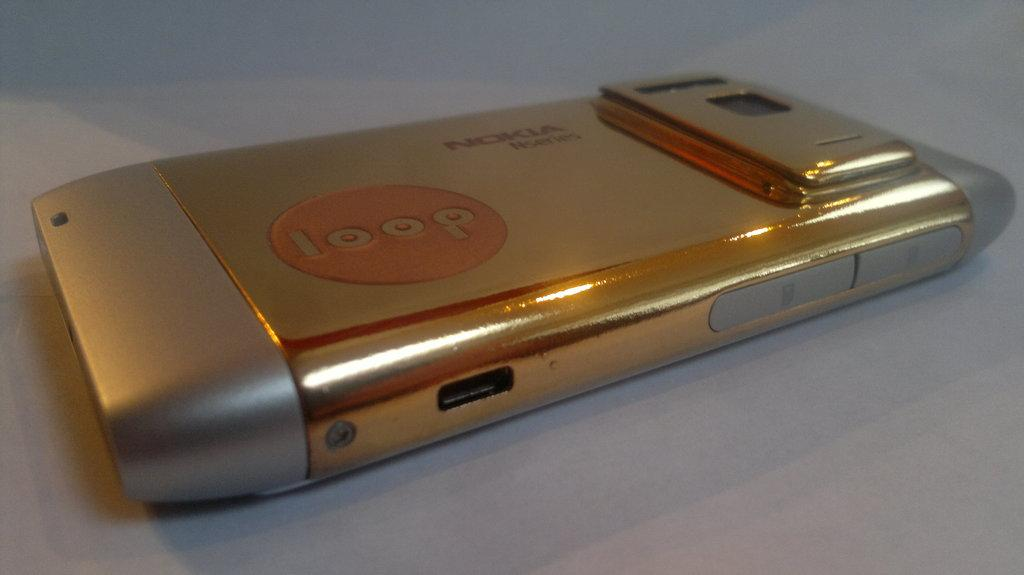<image>
Present a compact description of the photo's key features. a phone that is gold with the name Nokia at the top 